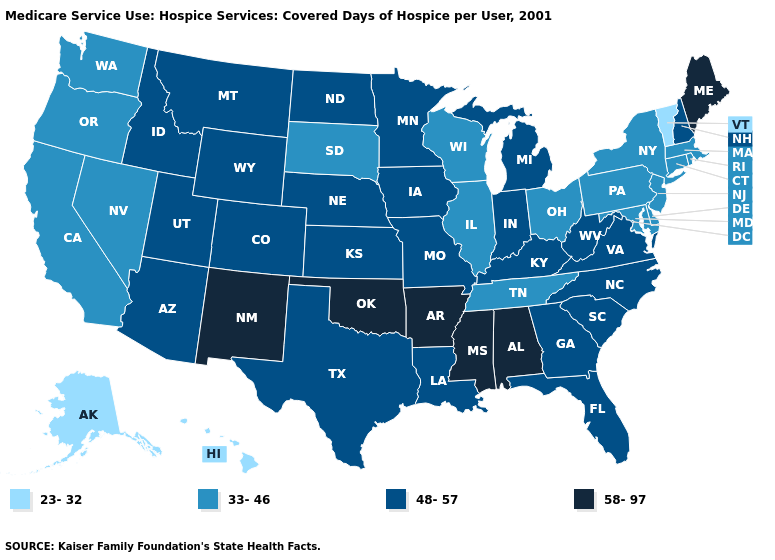What is the value of Virginia?
Concise answer only. 48-57. Among the states that border Washington , which have the highest value?
Be succinct. Idaho. What is the lowest value in states that border Oklahoma?
Write a very short answer. 48-57. What is the highest value in states that border Virginia?
Concise answer only. 48-57. What is the lowest value in the USA?
Short answer required. 23-32. What is the lowest value in the MidWest?
Keep it brief. 33-46. What is the lowest value in the MidWest?
Quick response, please. 33-46. What is the value of Maryland?
Be succinct. 33-46. What is the value of Indiana?
Answer briefly. 48-57. Does Maine have the highest value in the USA?
Quick response, please. Yes. What is the value of Maine?
Concise answer only. 58-97. Name the states that have a value in the range 58-97?
Answer briefly. Alabama, Arkansas, Maine, Mississippi, New Mexico, Oklahoma. Name the states that have a value in the range 23-32?
Keep it brief. Alaska, Hawaii, Vermont. What is the value of Utah?
Be succinct. 48-57. What is the highest value in the South ?
Keep it brief. 58-97. 